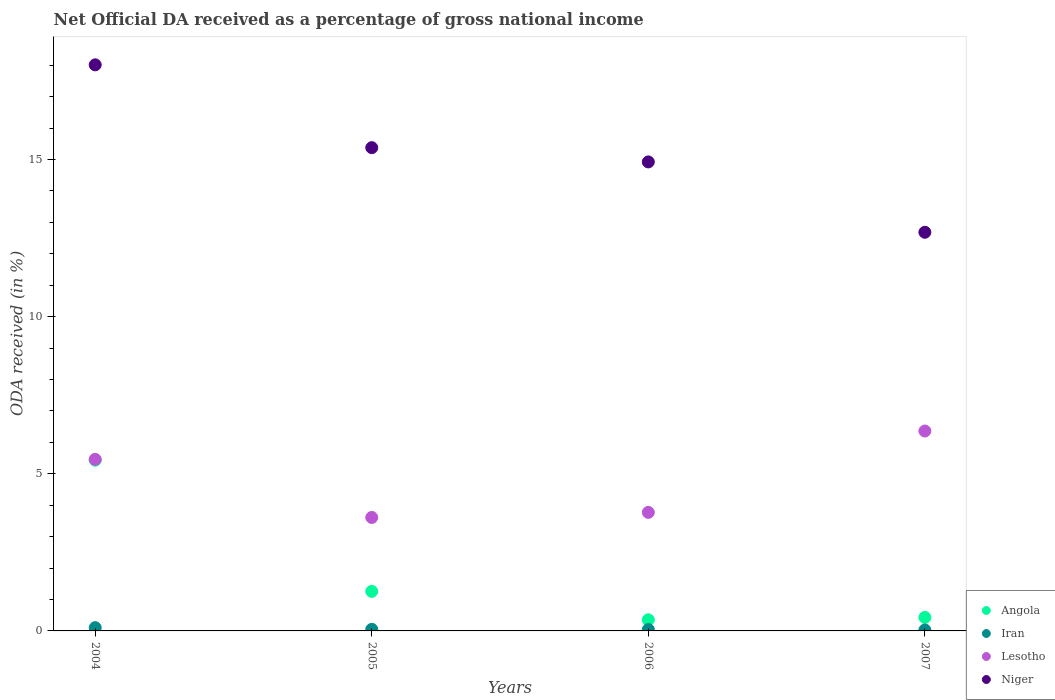How many different coloured dotlines are there?
Make the answer very short. 4. Is the number of dotlines equal to the number of legend labels?
Your answer should be compact. Yes. What is the net official DA received in Niger in 2007?
Offer a very short reply. 12.68. Across all years, what is the maximum net official DA received in Iran?
Your answer should be very brief. 0.1. Across all years, what is the minimum net official DA received in Iran?
Ensure brevity in your answer.  0.03. What is the total net official DA received in Niger in the graph?
Provide a short and direct response. 61. What is the difference between the net official DA received in Niger in 2005 and that in 2007?
Give a very brief answer. 2.69. What is the difference between the net official DA received in Angola in 2006 and the net official DA received in Niger in 2007?
Provide a short and direct response. -12.33. What is the average net official DA received in Niger per year?
Offer a terse response. 15.25. In the year 2004, what is the difference between the net official DA received in Angola and net official DA received in Niger?
Provide a short and direct response. -12.58. In how many years, is the net official DA received in Iran greater than 5 %?
Give a very brief answer. 0. What is the ratio of the net official DA received in Niger in 2005 to that in 2007?
Give a very brief answer. 1.21. Is the net official DA received in Niger in 2004 less than that in 2007?
Your answer should be compact. No. What is the difference between the highest and the second highest net official DA received in Angola?
Keep it short and to the point. 4.17. What is the difference between the highest and the lowest net official DA received in Angola?
Your answer should be compact. 5.08. In how many years, is the net official DA received in Lesotho greater than the average net official DA received in Lesotho taken over all years?
Provide a short and direct response. 2. Is the sum of the net official DA received in Angola in 2005 and 2006 greater than the maximum net official DA received in Niger across all years?
Ensure brevity in your answer.  No. Is it the case that in every year, the sum of the net official DA received in Niger and net official DA received in Iran  is greater than the sum of net official DA received in Lesotho and net official DA received in Angola?
Give a very brief answer. No. Is the net official DA received in Angola strictly greater than the net official DA received in Lesotho over the years?
Provide a short and direct response. No. Is the net official DA received in Lesotho strictly less than the net official DA received in Iran over the years?
Give a very brief answer. No. How many dotlines are there?
Your answer should be compact. 4. What is the difference between two consecutive major ticks on the Y-axis?
Provide a short and direct response. 5. Does the graph contain grids?
Provide a short and direct response. No. Where does the legend appear in the graph?
Provide a succinct answer. Bottom right. How are the legend labels stacked?
Your answer should be very brief. Vertical. What is the title of the graph?
Give a very brief answer. Net Official DA received as a percentage of gross national income. What is the label or title of the X-axis?
Offer a terse response. Years. What is the label or title of the Y-axis?
Offer a terse response. ODA received (in %). What is the ODA received (in %) in Angola in 2004?
Your answer should be very brief. 5.43. What is the ODA received (in %) of Iran in 2004?
Keep it short and to the point. 0.1. What is the ODA received (in %) of Lesotho in 2004?
Your answer should be very brief. 5.46. What is the ODA received (in %) of Niger in 2004?
Offer a terse response. 18.01. What is the ODA received (in %) of Angola in 2005?
Provide a succinct answer. 1.26. What is the ODA received (in %) in Iran in 2005?
Ensure brevity in your answer.  0.05. What is the ODA received (in %) of Lesotho in 2005?
Ensure brevity in your answer.  3.61. What is the ODA received (in %) of Niger in 2005?
Offer a very short reply. 15.38. What is the ODA received (in %) of Angola in 2006?
Keep it short and to the point. 0.35. What is the ODA received (in %) in Iran in 2006?
Offer a terse response. 0.04. What is the ODA received (in %) in Lesotho in 2006?
Offer a very short reply. 3.77. What is the ODA received (in %) in Niger in 2006?
Make the answer very short. 14.92. What is the ODA received (in %) in Angola in 2007?
Keep it short and to the point. 0.43. What is the ODA received (in %) of Iran in 2007?
Make the answer very short. 0.03. What is the ODA received (in %) in Lesotho in 2007?
Keep it short and to the point. 6.36. What is the ODA received (in %) of Niger in 2007?
Give a very brief answer. 12.68. Across all years, what is the maximum ODA received (in %) of Angola?
Make the answer very short. 5.43. Across all years, what is the maximum ODA received (in %) of Iran?
Your response must be concise. 0.1. Across all years, what is the maximum ODA received (in %) in Lesotho?
Keep it short and to the point. 6.36. Across all years, what is the maximum ODA received (in %) of Niger?
Provide a succinct answer. 18.01. Across all years, what is the minimum ODA received (in %) of Angola?
Your response must be concise. 0.35. Across all years, what is the minimum ODA received (in %) of Iran?
Give a very brief answer. 0.03. Across all years, what is the minimum ODA received (in %) in Lesotho?
Offer a terse response. 3.61. Across all years, what is the minimum ODA received (in %) of Niger?
Your answer should be very brief. 12.68. What is the total ODA received (in %) in Angola in the graph?
Provide a short and direct response. 7.48. What is the total ODA received (in %) in Iran in the graph?
Ensure brevity in your answer.  0.23. What is the total ODA received (in %) of Lesotho in the graph?
Your answer should be very brief. 19.2. What is the total ODA received (in %) of Niger in the graph?
Offer a terse response. 61. What is the difference between the ODA received (in %) in Angola in 2004 and that in 2005?
Provide a succinct answer. 4.17. What is the difference between the ODA received (in %) in Iran in 2004 and that in 2005?
Provide a short and direct response. 0.05. What is the difference between the ODA received (in %) in Lesotho in 2004 and that in 2005?
Keep it short and to the point. 1.85. What is the difference between the ODA received (in %) in Niger in 2004 and that in 2005?
Your answer should be compact. 2.64. What is the difference between the ODA received (in %) of Angola in 2004 and that in 2006?
Provide a succinct answer. 5.08. What is the difference between the ODA received (in %) of Iran in 2004 and that in 2006?
Give a very brief answer. 0.06. What is the difference between the ODA received (in %) of Lesotho in 2004 and that in 2006?
Give a very brief answer. 1.69. What is the difference between the ODA received (in %) of Niger in 2004 and that in 2006?
Your response must be concise. 3.09. What is the difference between the ODA received (in %) of Angola in 2004 and that in 2007?
Provide a short and direct response. 5. What is the difference between the ODA received (in %) in Iran in 2004 and that in 2007?
Your response must be concise. 0.07. What is the difference between the ODA received (in %) of Lesotho in 2004 and that in 2007?
Offer a terse response. -0.9. What is the difference between the ODA received (in %) of Niger in 2004 and that in 2007?
Keep it short and to the point. 5.33. What is the difference between the ODA received (in %) of Angola in 2005 and that in 2006?
Offer a very short reply. 0.9. What is the difference between the ODA received (in %) of Iran in 2005 and that in 2006?
Provide a short and direct response. 0. What is the difference between the ODA received (in %) in Lesotho in 2005 and that in 2006?
Give a very brief answer. -0.16. What is the difference between the ODA received (in %) in Niger in 2005 and that in 2006?
Provide a short and direct response. 0.45. What is the difference between the ODA received (in %) in Angola in 2005 and that in 2007?
Give a very brief answer. 0.83. What is the difference between the ODA received (in %) in Iran in 2005 and that in 2007?
Offer a very short reply. 0.02. What is the difference between the ODA received (in %) of Lesotho in 2005 and that in 2007?
Make the answer very short. -2.75. What is the difference between the ODA received (in %) of Niger in 2005 and that in 2007?
Give a very brief answer. 2.69. What is the difference between the ODA received (in %) in Angola in 2006 and that in 2007?
Your answer should be very brief. -0.08. What is the difference between the ODA received (in %) of Iran in 2006 and that in 2007?
Provide a short and direct response. 0.01. What is the difference between the ODA received (in %) of Lesotho in 2006 and that in 2007?
Give a very brief answer. -2.59. What is the difference between the ODA received (in %) in Niger in 2006 and that in 2007?
Your response must be concise. 2.24. What is the difference between the ODA received (in %) in Angola in 2004 and the ODA received (in %) in Iran in 2005?
Your response must be concise. 5.38. What is the difference between the ODA received (in %) of Angola in 2004 and the ODA received (in %) of Lesotho in 2005?
Your answer should be very brief. 1.82. What is the difference between the ODA received (in %) of Angola in 2004 and the ODA received (in %) of Niger in 2005?
Provide a short and direct response. -9.94. What is the difference between the ODA received (in %) in Iran in 2004 and the ODA received (in %) in Lesotho in 2005?
Provide a short and direct response. -3.51. What is the difference between the ODA received (in %) of Iran in 2004 and the ODA received (in %) of Niger in 2005?
Offer a very short reply. -15.27. What is the difference between the ODA received (in %) in Lesotho in 2004 and the ODA received (in %) in Niger in 2005?
Give a very brief answer. -9.92. What is the difference between the ODA received (in %) in Angola in 2004 and the ODA received (in %) in Iran in 2006?
Provide a short and direct response. 5.39. What is the difference between the ODA received (in %) of Angola in 2004 and the ODA received (in %) of Lesotho in 2006?
Provide a succinct answer. 1.66. What is the difference between the ODA received (in %) of Angola in 2004 and the ODA received (in %) of Niger in 2006?
Offer a very short reply. -9.49. What is the difference between the ODA received (in %) of Iran in 2004 and the ODA received (in %) of Lesotho in 2006?
Your answer should be compact. -3.67. What is the difference between the ODA received (in %) in Iran in 2004 and the ODA received (in %) in Niger in 2006?
Offer a very short reply. -14.82. What is the difference between the ODA received (in %) of Lesotho in 2004 and the ODA received (in %) of Niger in 2006?
Provide a succinct answer. -9.46. What is the difference between the ODA received (in %) in Angola in 2004 and the ODA received (in %) in Iran in 2007?
Offer a terse response. 5.4. What is the difference between the ODA received (in %) in Angola in 2004 and the ODA received (in %) in Lesotho in 2007?
Your response must be concise. -0.93. What is the difference between the ODA received (in %) in Angola in 2004 and the ODA received (in %) in Niger in 2007?
Your answer should be very brief. -7.25. What is the difference between the ODA received (in %) of Iran in 2004 and the ODA received (in %) of Lesotho in 2007?
Your answer should be compact. -6.26. What is the difference between the ODA received (in %) of Iran in 2004 and the ODA received (in %) of Niger in 2007?
Offer a very short reply. -12.58. What is the difference between the ODA received (in %) of Lesotho in 2004 and the ODA received (in %) of Niger in 2007?
Make the answer very short. -7.23. What is the difference between the ODA received (in %) of Angola in 2005 and the ODA received (in %) of Iran in 2006?
Offer a terse response. 1.21. What is the difference between the ODA received (in %) in Angola in 2005 and the ODA received (in %) in Lesotho in 2006?
Keep it short and to the point. -2.51. What is the difference between the ODA received (in %) of Angola in 2005 and the ODA received (in %) of Niger in 2006?
Offer a terse response. -13.67. What is the difference between the ODA received (in %) in Iran in 2005 and the ODA received (in %) in Lesotho in 2006?
Make the answer very short. -3.72. What is the difference between the ODA received (in %) of Iran in 2005 and the ODA received (in %) of Niger in 2006?
Provide a short and direct response. -14.87. What is the difference between the ODA received (in %) of Lesotho in 2005 and the ODA received (in %) of Niger in 2006?
Your response must be concise. -11.31. What is the difference between the ODA received (in %) in Angola in 2005 and the ODA received (in %) in Iran in 2007?
Offer a terse response. 1.23. What is the difference between the ODA received (in %) of Angola in 2005 and the ODA received (in %) of Lesotho in 2007?
Your answer should be compact. -5.1. What is the difference between the ODA received (in %) of Angola in 2005 and the ODA received (in %) of Niger in 2007?
Your response must be concise. -11.43. What is the difference between the ODA received (in %) of Iran in 2005 and the ODA received (in %) of Lesotho in 2007?
Keep it short and to the point. -6.31. What is the difference between the ODA received (in %) of Iran in 2005 and the ODA received (in %) of Niger in 2007?
Offer a very short reply. -12.64. What is the difference between the ODA received (in %) in Lesotho in 2005 and the ODA received (in %) in Niger in 2007?
Provide a short and direct response. -9.07. What is the difference between the ODA received (in %) in Angola in 2006 and the ODA received (in %) in Iran in 2007?
Your answer should be very brief. 0.32. What is the difference between the ODA received (in %) of Angola in 2006 and the ODA received (in %) of Lesotho in 2007?
Your response must be concise. -6.01. What is the difference between the ODA received (in %) of Angola in 2006 and the ODA received (in %) of Niger in 2007?
Provide a short and direct response. -12.33. What is the difference between the ODA received (in %) of Iran in 2006 and the ODA received (in %) of Lesotho in 2007?
Your answer should be very brief. -6.32. What is the difference between the ODA received (in %) in Iran in 2006 and the ODA received (in %) in Niger in 2007?
Offer a very short reply. -12.64. What is the difference between the ODA received (in %) in Lesotho in 2006 and the ODA received (in %) in Niger in 2007?
Provide a succinct answer. -8.91. What is the average ODA received (in %) in Angola per year?
Provide a succinct answer. 1.87. What is the average ODA received (in %) of Iran per year?
Give a very brief answer. 0.06. What is the average ODA received (in %) in Lesotho per year?
Your answer should be compact. 4.8. What is the average ODA received (in %) in Niger per year?
Offer a terse response. 15.25. In the year 2004, what is the difference between the ODA received (in %) of Angola and ODA received (in %) of Iran?
Ensure brevity in your answer.  5.33. In the year 2004, what is the difference between the ODA received (in %) in Angola and ODA received (in %) in Lesotho?
Make the answer very short. -0.03. In the year 2004, what is the difference between the ODA received (in %) of Angola and ODA received (in %) of Niger?
Your response must be concise. -12.58. In the year 2004, what is the difference between the ODA received (in %) of Iran and ODA received (in %) of Lesotho?
Your answer should be compact. -5.36. In the year 2004, what is the difference between the ODA received (in %) of Iran and ODA received (in %) of Niger?
Keep it short and to the point. -17.91. In the year 2004, what is the difference between the ODA received (in %) of Lesotho and ODA received (in %) of Niger?
Ensure brevity in your answer.  -12.55. In the year 2005, what is the difference between the ODA received (in %) of Angola and ODA received (in %) of Iran?
Keep it short and to the point. 1.21. In the year 2005, what is the difference between the ODA received (in %) in Angola and ODA received (in %) in Lesotho?
Give a very brief answer. -2.35. In the year 2005, what is the difference between the ODA received (in %) in Angola and ODA received (in %) in Niger?
Your response must be concise. -14.12. In the year 2005, what is the difference between the ODA received (in %) in Iran and ODA received (in %) in Lesotho?
Offer a very short reply. -3.56. In the year 2005, what is the difference between the ODA received (in %) of Iran and ODA received (in %) of Niger?
Your answer should be very brief. -15.33. In the year 2005, what is the difference between the ODA received (in %) in Lesotho and ODA received (in %) in Niger?
Your answer should be very brief. -11.77. In the year 2006, what is the difference between the ODA received (in %) of Angola and ODA received (in %) of Iran?
Your answer should be compact. 0.31. In the year 2006, what is the difference between the ODA received (in %) of Angola and ODA received (in %) of Lesotho?
Keep it short and to the point. -3.42. In the year 2006, what is the difference between the ODA received (in %) of Angola and ODA received (in %) of Niger?
Make the answer very short. -14.57. In the year 2006, what is the difference between the ODA received (in %) in Iran and ODA received (in %) in Lesotho?
Provide a succinct answer. -3.73. In the year 2006, what is the difference between the ODA received (in %) in Iran and ODA received (in %) in Niger?
Provide a succinct answer. -14.88. In the year 2006, what is the difference between the ODA received (in %) of Lesotho and ODA received (in %) of Niger?
Make the answer very short. -11.15. In the year 2007, what is the difference between the ODA received (in %) of Angola and ODA received (in %) of Iran?
Offer a very short reply. 0.4. In the year 2007, what is the difference between the ODA received (in %) in Angola and ODA received (in %) in Lesotho?
Ensure brevity in your answer.  -5.93. In the year 2007, what is the difference between the ODA received (in %) of Angola and ODA received (in %) of Niger?
Your response must be concise. -12.26. In the year 2007, what is the difference between the ODA received (in %) of Iran and ODA received (in %) of Lesotho?
Make the answer very short. -6.33. In the year 2007, what is the difference between the ODA received (in %) of Iran and ODA received (in %) of Niger?
Your answer should be very brief. -12.65. In the year 2007, what is the difference between the ODA received (in %) in Lesotho and ODA received (in %) in Niger?
Make the answer very short. -6.32. What is the ratio of the ODA received (in %) of Angola in 2004 to that in 2005?
Provide a succinct answer. 4.32. What is the ratio of the ODA received (in %) in Iran in 2004 to that in 2005?
Make the answer very short. 2.09. What is the ratio of the ODA received (in %) in Lesotho in 2004 to that in 2005?
Offer a terse response. 1.51. What is the ratio of the ODA received (in %) in Niger in 2004 to that in 2005?
Keep it short and to the point. 1.17. What is the ratio of the ODA received (in %) of Angola in 2004 to that in 2006?
Keep it short and to the point. 15.35. What is the ratio of the ODA received (in %) of Iran in 2004 to that in 2006?
Provide a short and direct response. 2.32. What is the ratio of the ODA received (in %) in Lesotho in 2004 to that in 2006?
Make the answer very short. 1.45. What is the ratio of the ODA received (in %) in Niger in 2004 to that in 2006?
Keep it short and to the point. 1.21. What is the ratio of the ODA received (in %) of Angola in 2004 to that in 2007?
Offer a terse response. 12.65. What is the ratio of the ODA received (in %) of Iran in 2004 to that in 2007?
Ensure brevity in your answer.  3.44. What is the ratio of the ODA received (in %) in Lesotho in 2004 to that in 2007?
Ensure brevity in your answer.  0.86. What is the ratio of the ODA received (in %) of Niger in 2004 to that in 2007?
Offer a terse response. 1.42. What is the ratio of the ODA received (in %) in Angola in 2005 to that in 2006?
Your answer should be very brief. 3.56. What is the ratio of the ODA received (in %) in Iran in 2005 to that in 2006?
Offer a terse response. 1.11. What is the ratio of the ODA received (in %) in Lesotho in 2005 to that in 2006?
Provide a succinct answer. 0.96. What is the ratio of the ODA received (in %) of Niger in 2005 to that in 2006?
Your answer should be compact. 1.03. What is the ratio of the ODA received (in %) in Angola in 2005 to that in 2007?
Offer a very short reply. 2.93. What is the ratio of the ODA received (in %) of Iran in 2005 to that in 2007?
Your answer should be compact. 1.64. What is the ratio of the ODA received (in %) of Lesotho in 2005 to that in 2007?
Provide a short and direct response. 0.57. What is the ratio of the ODA received (in %) of Niger in 2005 to that in 2007?
Provide a short and direct response. 1.21. What is the ratio of the ODA received (in %) in Angola in 2006 to that in 2007?
Provide a short and direct response. 0.82. What is the ratio of the ODA received (in %) in Iran in 2006 to that in 2007?
Give a very brief answer. 1.48. What is the ratio of the ODA received (in %) in Lesotho in 2006 to that in 2007?
Your answer should be very brief. 0.59. What is the ratio of the ODA received (in %) in Niger in 2006 to that in 2007?
Keep it short and to the point. 1.18. What is the difference between the highest and the second highest ODA received (in %) of Angola?
Your answer should be compact. 4.17. What is the difference between the highest and the second highest ODA received (in %) of Iran?
Give a very brief answer. 0.05. What is the difference between the highest and the second highest ODA received (in %) of Lesotho?
Offer a terse response. 0.9. What is the difference between the highest and the second highest ODA received (in %) of Niger?
Make the answer very short. 2.64. What is the difference between the highest and the lowest ODA received (in %) in Angola?
Keep it short and to the point. 5.08. What is the difference between the highest and the lowest ODA received (in %) of Iran?
Your response must be concise. 0.07. What is the difference between the highest and the lowest ODA received (in %) of Lesotho?
Keep it short and to the point. 2.75. What is the difference between the highest and the lowest ODA received (in %) of Niger?
Your answer should be compact. 5.33. 